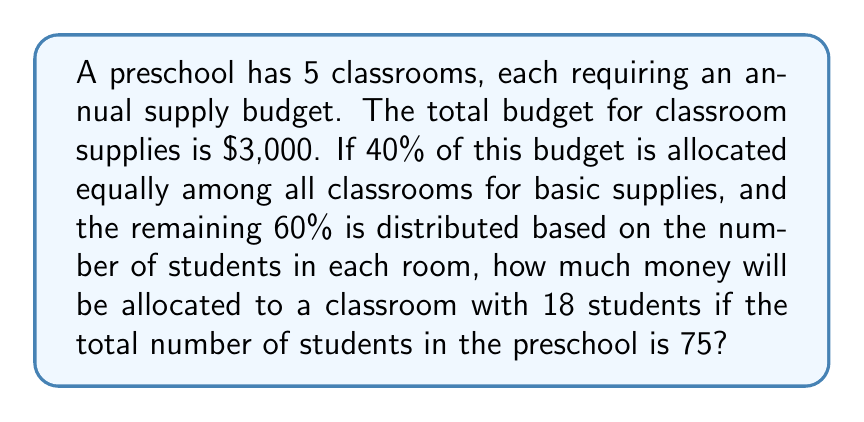Teach me how to tackle this problem. Let's break this down step-by-step:

1. Calculate the amount allocated for basic supplies:
   $$ 40\% \text{ of } \$3,000 = 0.40 \times \$3,000 = \$1,200 $$

2. Calculate the amount per classroom for basic supplies:
   $$ \$1,200 \div 5 \text{ classrooms} = \$240 \text{ per classroom} $$

3. Calculate the remaining budget for student-based allocation:
   $$ 60\% \text{ of } \$3,000 = 0.60 \times \$3,000 = \$1,800 $$

4. Calculate the per-student allocation:
   $$ \$1,800 \div 75 \text{ students} = \$24 \text{ per student} $$

5. Calculate the student-based allocation for the classroom with 18 students:
   $$ 18 \text{ students} \times \$24 \text{ per student} = \$432 $$

6. Sum up the basic supply allocation and student-based allocation:
   $$ \$240 + \$432 = \$672 $$

Therefore, the classroom with 18 students will be allocated $672.
Answer: $672 